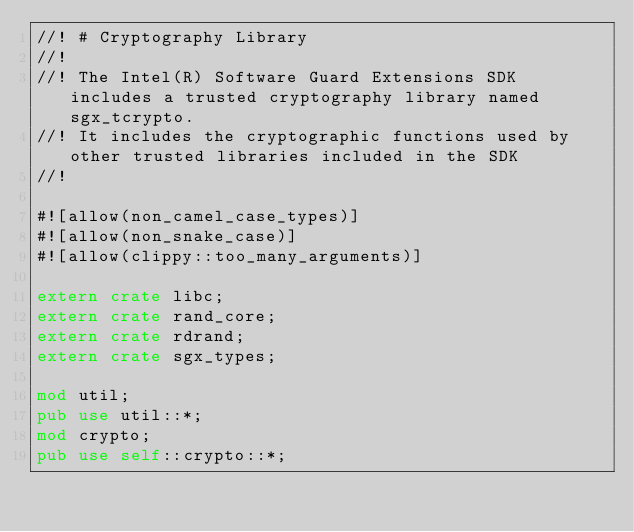Convert code to text. <code><loc_0><loc_0><loc_500><loc_500><_Rust_>//! # Cryptography Library
//!
//! The Intel(R) Software Guard Extensions SDK includes a trusted cryptography library named sgx_tcrypto.
//! It includes the cryptographic functions used by other trusted libraries included in the SDK
//!

#![allow(non_camel_case_types)]
#![allow(non_snake_case)]
#![allow(clippy::too_many_arguments)]

extern crate libc;
extern crate rand_core;
extern crate rdrand;
extern crate sgx_types;

mod util;
pub use util::*;
mod crypto;
pub use self::crypto::*;
</code> 